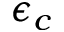Convert formula to latex. <formula><loc_0><loc_0><loc_500><loc_500>\epsilon _ { c }</formula> 